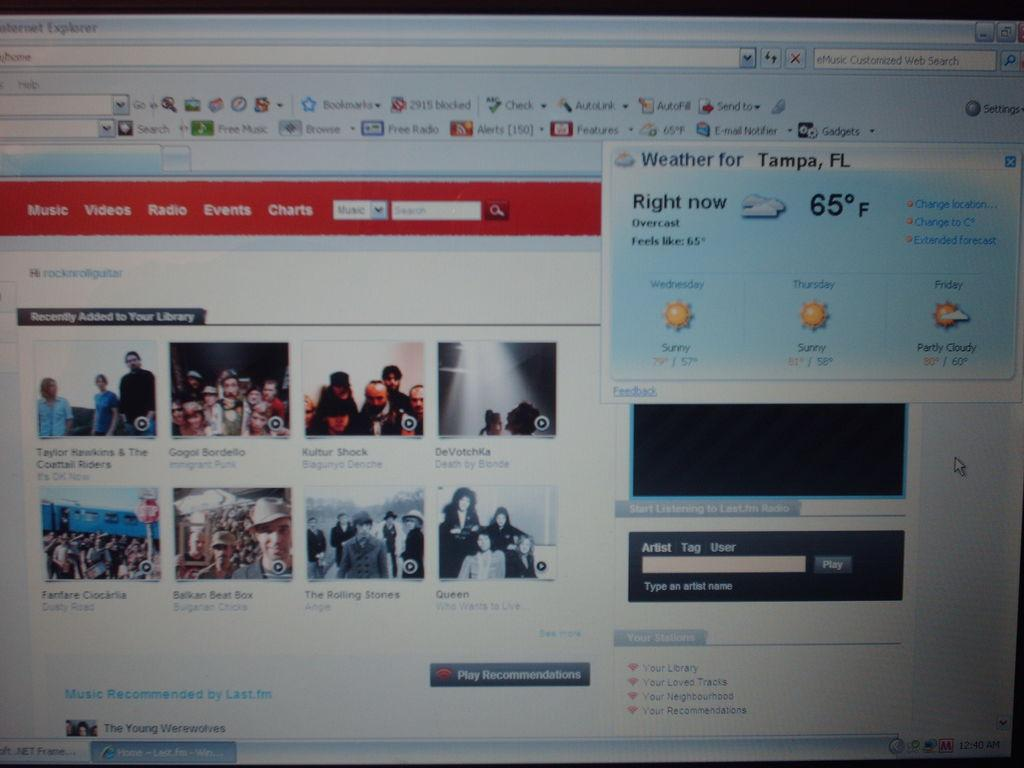Provide a one-sentence caption for the provided image. According to the news website, it is currently 65* in Tampa, FL. 